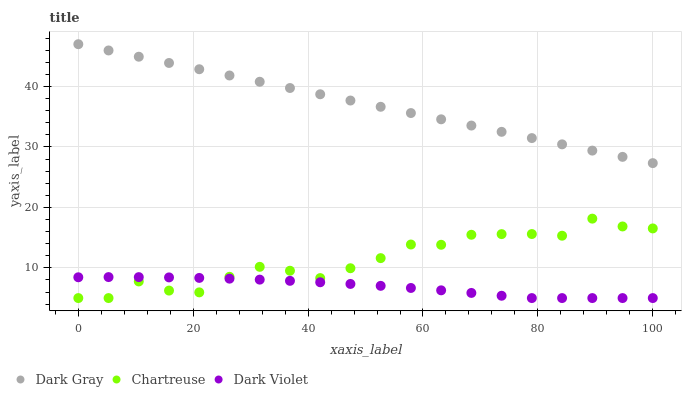Does Dark Violet have the minimum area under the curve?
Answer yes or no. Yes. Does Dark Gray have the maximum area under the curve?
Answer yes or no. Yes. Does Chartreuse have the minimum area under the curve?
Answer yes or no. No. Does Chartreuse have the maximum area under the curve?
Answer yes or no. No. Is Dark Gray the smoothest?
Answer yes or no. Yes. Is Chartreuse the roughest?
Answer yes or no. Yes. Is Dark Violet the smoothest?
Answer yes or no. No. Is Dark Violet the roughest?
Answer yes or no. No. Does Chartreuse have the lowest value?
Answer yes or no. Yes. Does Dark Gray have the highest value?
Answer yes or no. Yes. Does Chartreuse have the highest value?
Answer yes or no. No. Is Chartreuse less than Dark Gray?
Answer yes or no. Yes. Is Dark Gray greater than Dark Violet?
Answer yes or no. Yes. Does Chartreuse intersect Dark Violet?
Answer yes or no. Yes. Is Chartreuse less than Dark Violet?
Answer yes or no. No. Is Chartreuse greater than Dark Violet?
Answer yes or no. No. Does Chartreuse intersect Dark Gray?
Answer yes or no. No. 